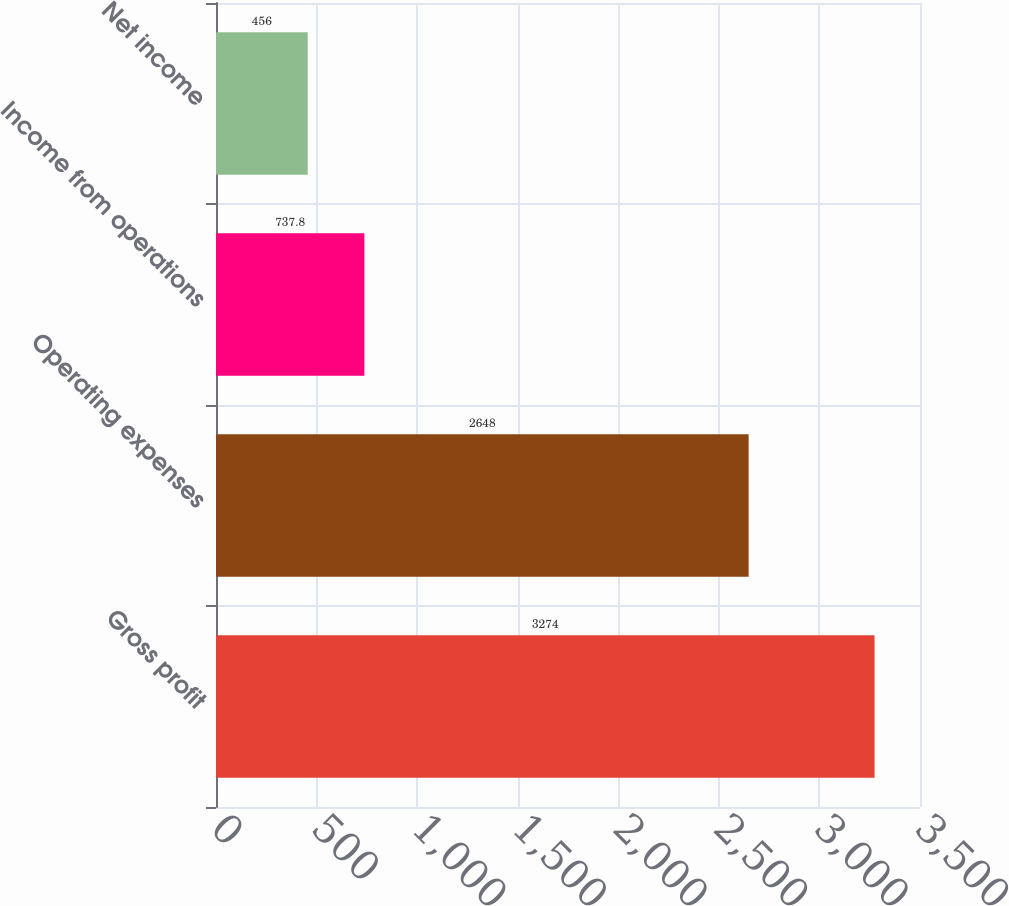<chart> <loc_0><loc_0><loc_500><loc_500><bar_chart><fcel>Gross profit<fcel>Operating expenses<fcel>Income from operations<fcel>Net income<nl><fcel>3274<fcel>2648<fcel>737.8<fcel>456<nl></chart> 